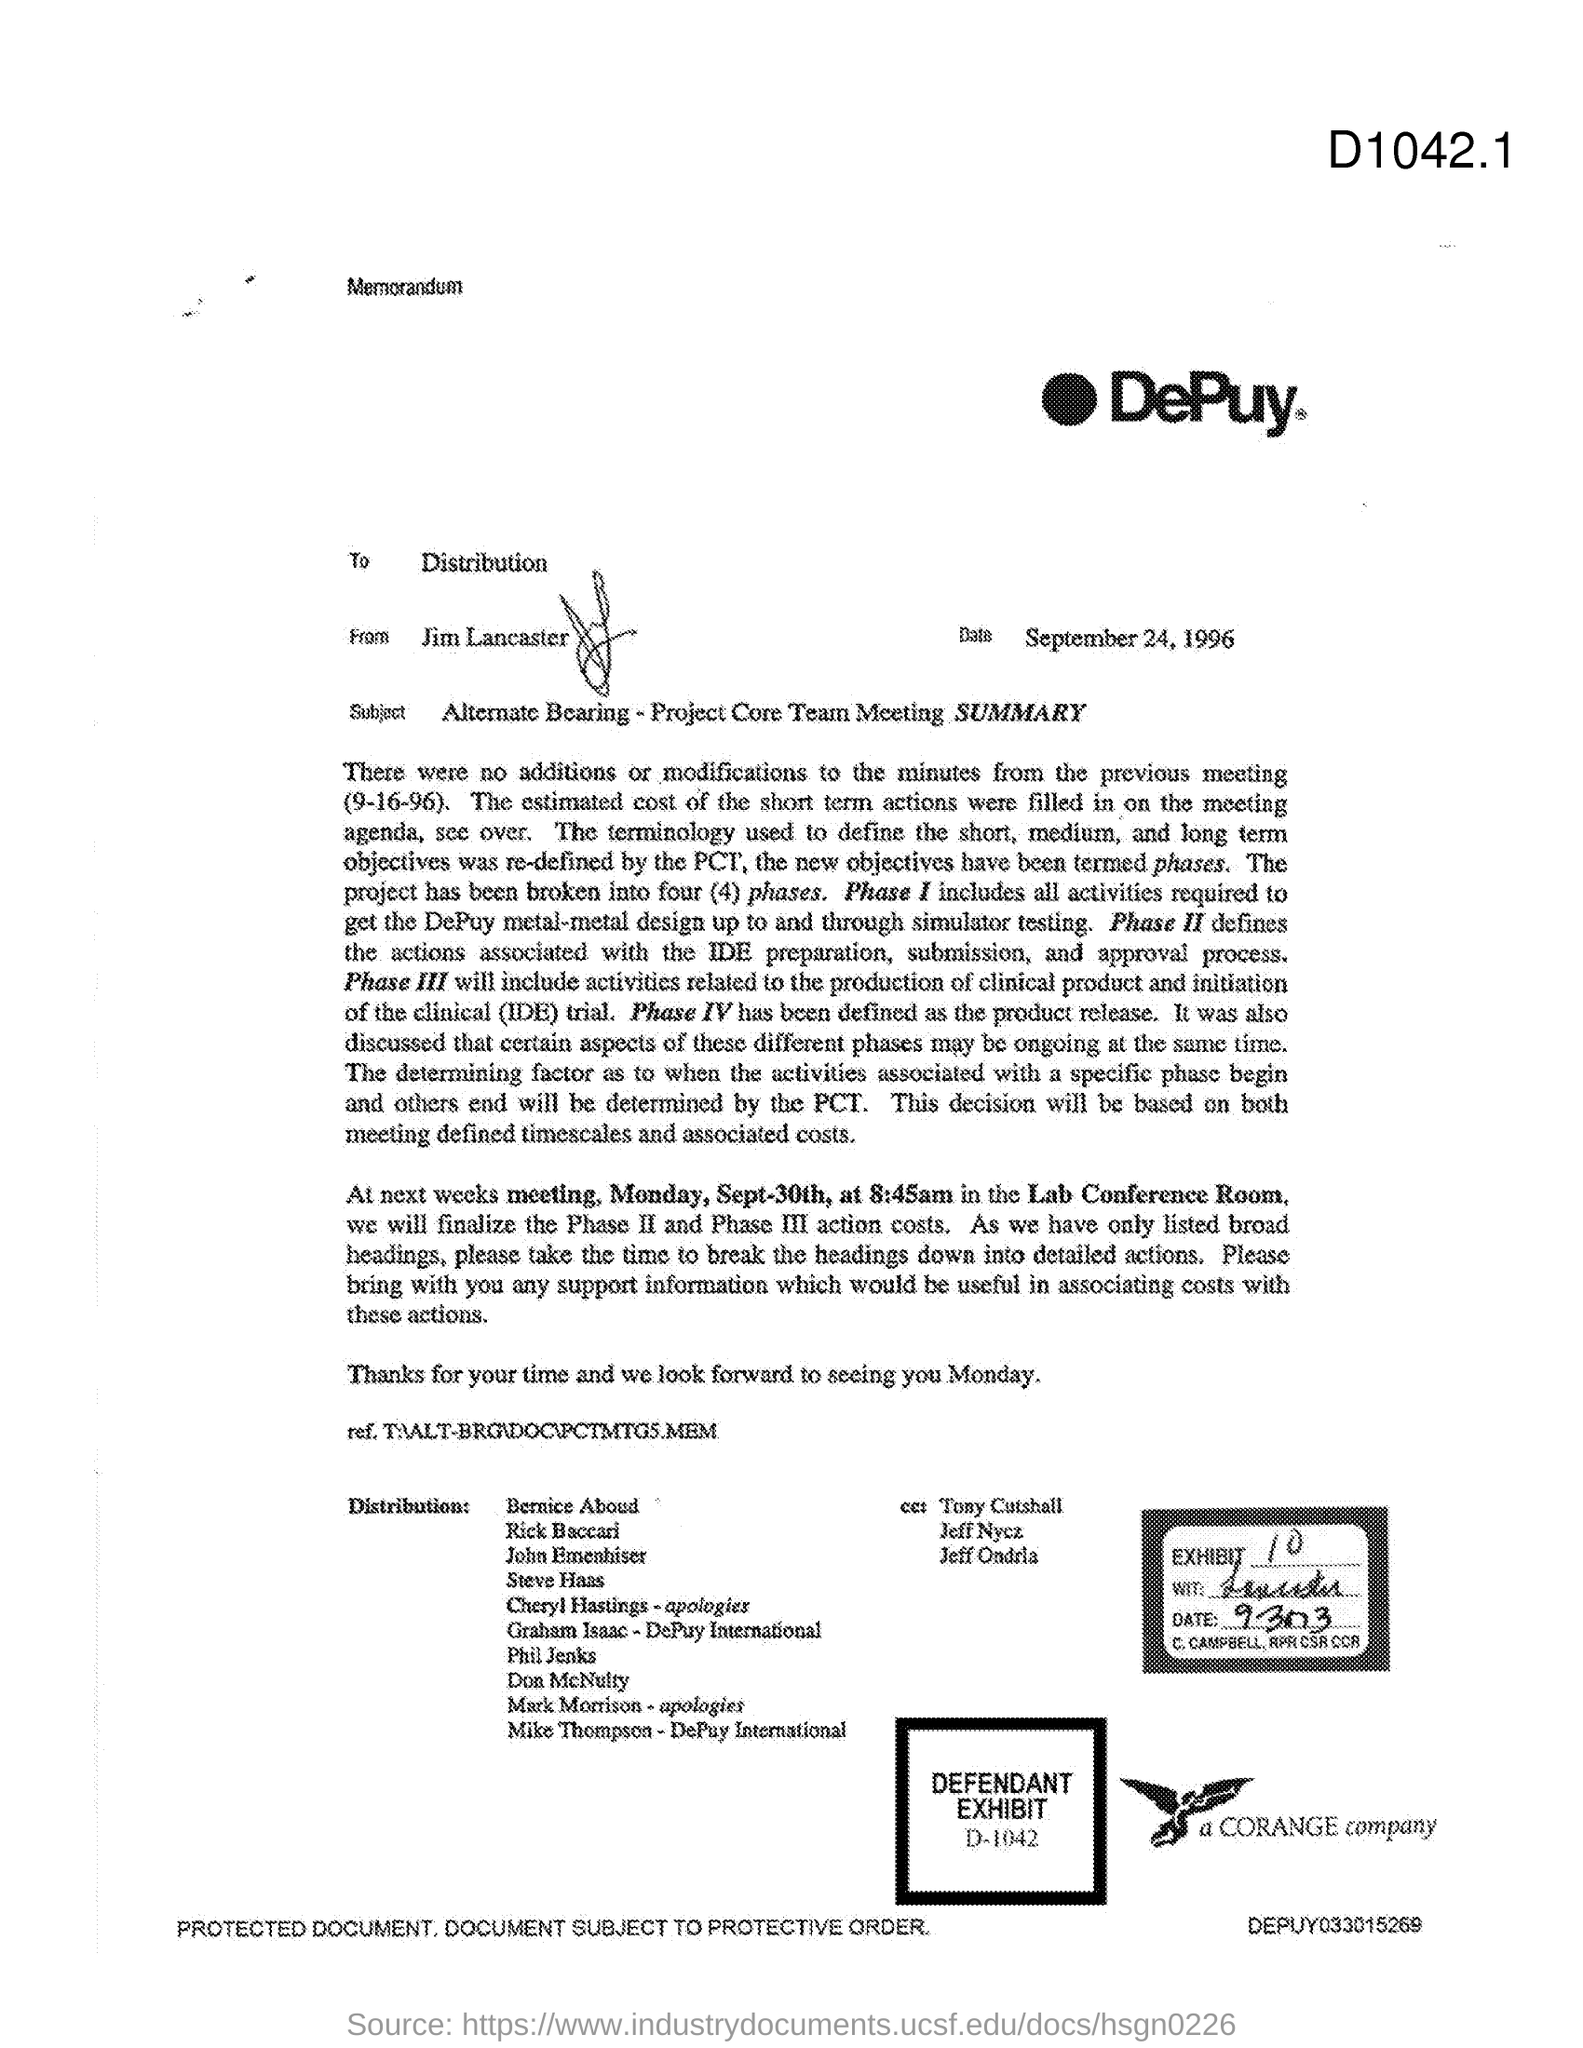To Whom is this memorandum addressed to?
Keep it short and to the point. Distribution. Who is the memorandum from?
Your answer should be very brief. Jim Lancaster. What is the Date?
Provide a short and direct response. September 24, 1996. Where is the Next meeting held?
Provide a short and direct response. Lab Conference Room. 